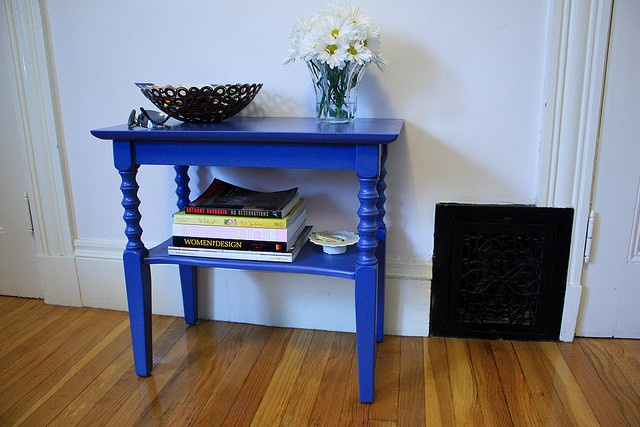Describe the objects in this image and their specific colors. I can see book in gray, black, and navy tones, bowl in gray, black, darkgray, and navy tones, vase in gray, black, lightblue, and blue tones, book in gray, lavender, and violet tones, and book in gray, khaki, and tan tones in this image. 